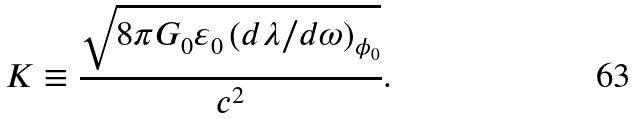Convert formula to latex. <formula><loc_0><loc_0><loc_500><loc_500>K \equiv \frac { \sqrt { 8 \pi G _ { 0 } \varepsilon _ { 0 } \left ( d \lambda / d \omega \right ) _ { \phi _ { 0 } } } } { c ^ { 2 } } .</formula> 